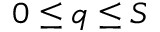<formula> <loc_0><loc_0><loc_500><loc_500>0 \leq q \leq S</formula> 